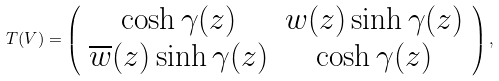<formula> <loc_0><loc_0><loc_500><loc_500>T ( V ) = \left ( \begin{array} { c c } \cosh \gamma ( z ) & w ( z ) \sinh \gamma ( z ) \\ \overline { w } ( z ) \sinh \gamma ( z ) & \cosh \gamma ( z ) \\ \end{array} \right ) ,</formula> 